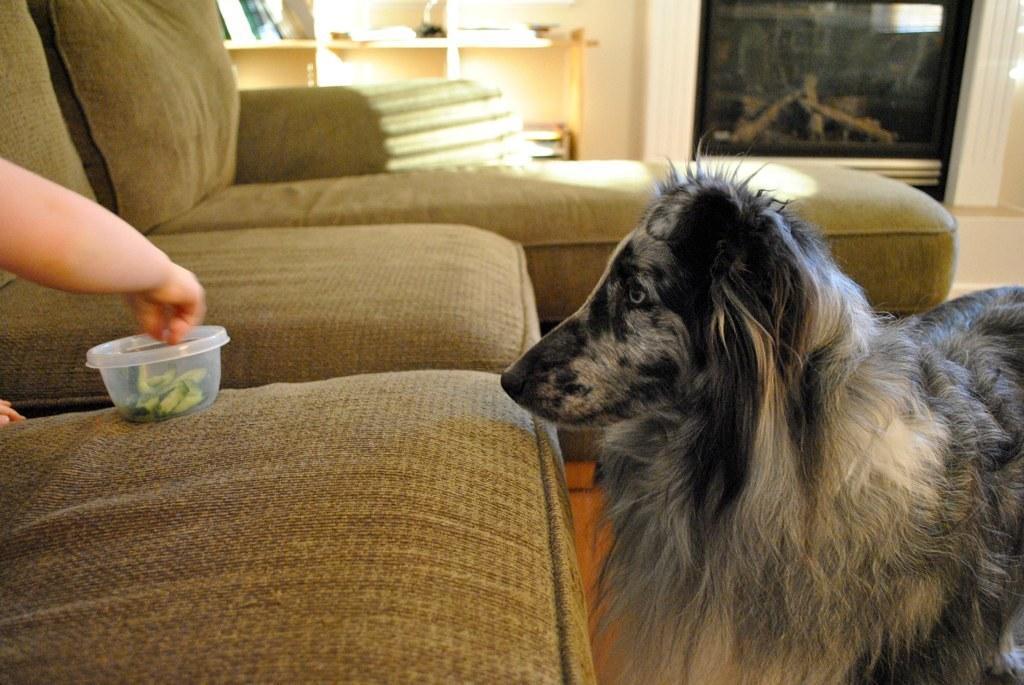How would you summarize this image in a sentence or two? In the picture we can see inside the house with some sofas on it, we can see a person's hand holding a plastic box and near the sofa we can see a dog on the floor and in the background, we can see a wall with racks and some things are kept at it and beside it we can see a black color door. 